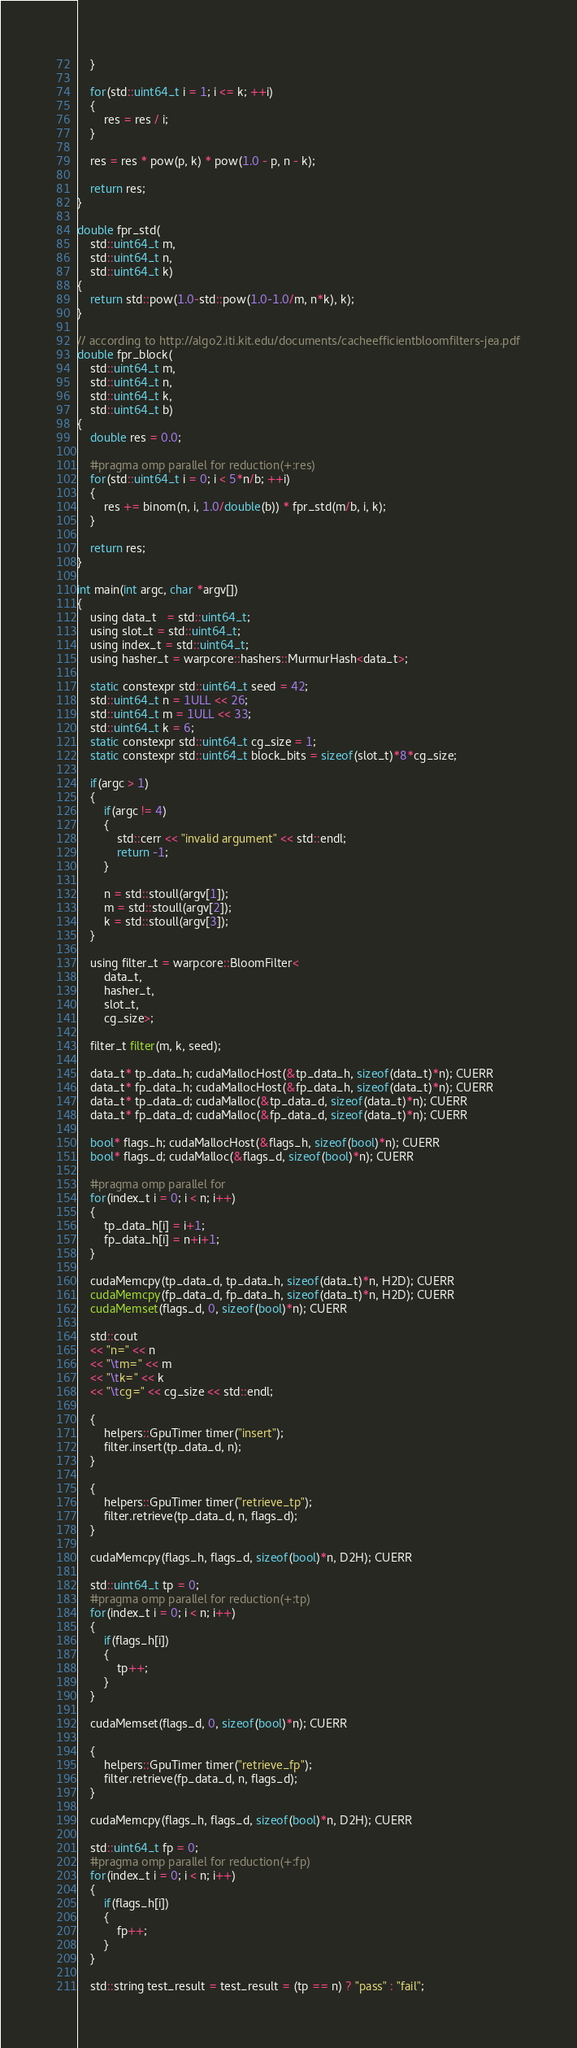Convert code to text. <code><loc_0><loc_0><loc_500><loc_500><_Cuda_>    }

    for(std::uint64_t i = 1; i <= k; ++i)
    {
        res = res / i;
    }

    res = res * pow(p, k) * pow(1.0 - p, n - k);

    return res;
}

double fpr_std(
    std::uint64_t m,
    std::uint64_t n,
    std::uint64_t k)
{
    return std::pow(1.0-std::pow(1.0-1.0/m, n*k), k);
}

// according to http://algo2.iti.kit.edu/documents/cacheefficientbloomfilters-jea.pdf
double fpr_block(
    std::uint64_t m,
    std::uint64_t n,
    std::uint64_t k,
    std::uint64_t b)
{
    double res = 0.0;

    #pragma omp parallel for reduction(+:res)
    for(std::uint64_t i = 0; i < 5*n/b; ++i)
    {
        res += binom(n, i, 1.0/double(b)) * fpr_std(m/b, i, k);
    }

    return res;
}

int main(int argc, char *argv[])
{
    using data_t   = std::uint64_t;
    using slot_t = std::uint64_t;
    using index_t = std::uint64_t;
    using hasher_t = warpcore::hashers::MurmurHash<data_t>;

    static constexpr std::uint64_t seed = 42;
    std::uint64_t n = 1ULL << 26;
    std::uint64_t m = 1ULL << 33;
    std::uint64_t k = 6;
    static constexpr std::uint64_t cg_size = 1;
    static constexpr std::uint64_t block_bits = sizeof(slot_t)*8*cg_size;

    if(argc > 1)
    {
        if(argc != 4)
        {
            std::cerr << "invalid argument" << std::endl;
            return -1;
        }

        n = std::stoull(argv[1]);
        m = std::stoull(argv[2]);
        k = std::stoull(argv[3]);
    }

    using filter_t = warpcore::BloomFilter<
        data_t,
        hasher_t,
        slot_t,
        cg_size>;

    filter_t filter(m, k, seed);

    data_t* tp_data_h; cudaMallocHost(&tp_data_h, sizeof(data_t)*n); CUERR
    data_t* fp_data_h; cudaMallocHost(&fp_data_h, sizeof(data_t)*n); CUERR
    data_t* tp_data_d; cudaMalloc(&tp_data_d, sizeof(data_t)*n); CUERR
    data_t* fp_data_d; cudaMalloc(&fp_data_d, sizeof(data_t)*n); CUERR

    bool* flags_h; cudaMallocHost(&flags_h, sizeof(bool)*n); CUERR
    bool* flags_d; cudaMalloc(&flags_d, sizeof(bool)*n); CUERR

    #pragma omp parallel for
    for(index_t i = 0; i < n; i++)
    {
        tp_data_h[i] = i+1;
        fp_data_h[i] = n+i+1;
    }

    cudaMemcpy(tp_data_d, tp_data_h, sizeof(data_t)*n, H2D); CUERR
    cudaMemcpy(fp_data_d, fp_data_h, sizeof(data_t)*n, H2D); CUERR
    cudaMemset(flags_d, 0, sizeof(bool)*n); CUERR

    std::cout
    << "n=" << n
    << "\tm=" << m
    << "\tk=" << k
    << "\tcg=" << cg_size << std::endl;

    {
        helpers::GpuTimer timer("insert");
        filter.insert(tp_data_d, n);
    }

    {
        helpers::GpuTimer timer("retrieve_tp");
        filter.retrieve(tp_data_d, n, flags_d);
    }

    cudaMemcpy(flags_h, flags_d, sizeof(bool)*n, D2H); CUERR

    std::uint64_t tp = 0;
    #pragma omp parallel for reduction(+:tp)
    for(index_t i = 0; i < n; i++)
    {
        if(flags_h[i])
        {
            tp++;
        }
    }

    cudaMemset(flags_d, 0, sizeof(bool)*n); CUERR

    {
        helpers::GpuTimer timer("retrieve_fp");
        filter.retrieve(fp_data_d, n, flags_d);
    }

    cudaMemcpy(flags_h, flags_d, sizeof(bool)*n, D2H); CUERR

    std::uint64_t fp = 0;
    #pragma omp parallel for reduction(+:fp)
    for(index_t i = 0; i < n; i++)
    {
        if(flags_h[i])
        {
            fp++;
        }
    }

    std::string test_result = test_result = (tp == n) ? "pass" : "fail";</code> 